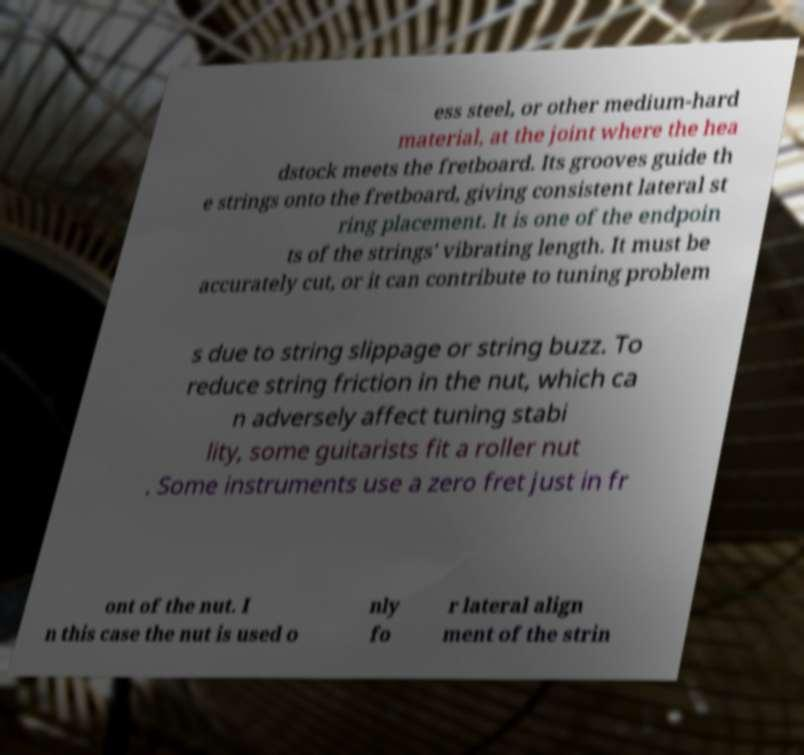Can you accurately transcribe the text from the provided image for me? ess steel, or other medium-hard material, at the joint where the hea dstock meets the fretboard. Its grooves guide th e strings onto the fretboard, giving consistent lateral st ring placement. It is one of the endpoin ts of the strings' vibrating length. It must be accurately cut, or it can contribute to tuning problem s due to string slippage or string buzz. To reduce string friction in the nut, which ca n adversely affect tuning stabi lity, some guitarists fit a roller nut . Some instruments use a zero fret just in fr ont of the nut. I n this case the nut is used o nly fo r lateral align ment of the strin 